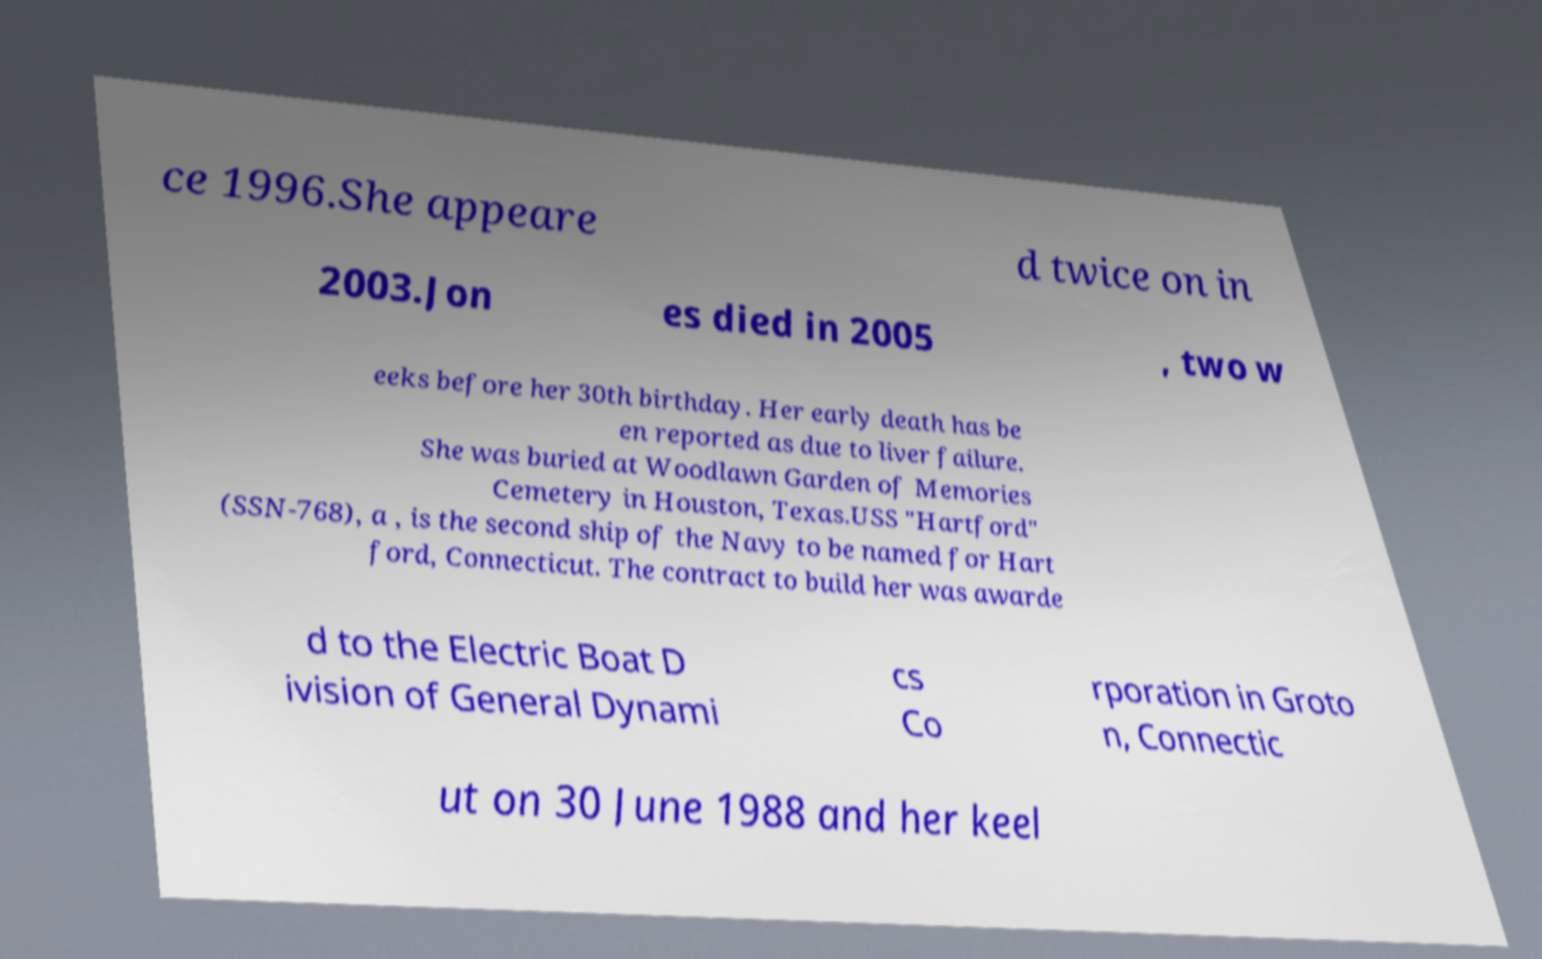Could you assist in decoding the text presented in this image and type it out clearly? ce 1996.She appeare d twice on in 2003.Jon es died in 2005 , two w eeks before her 30th birthday. Her early death has be en reported as due to liver failure. She was buried at Woodlawn Garden of Memories Cemetery in Houston, Texas.USS "Hartford" (SSN-768), a , is the second ship of the Navy to be named for Hart ford, Connecticut. The contract to build her was awarde d to the Electric Boat D ivision of General Dynami cs Co rporation in Groto n, Connectic ut on 30 June 1988 and her keel 